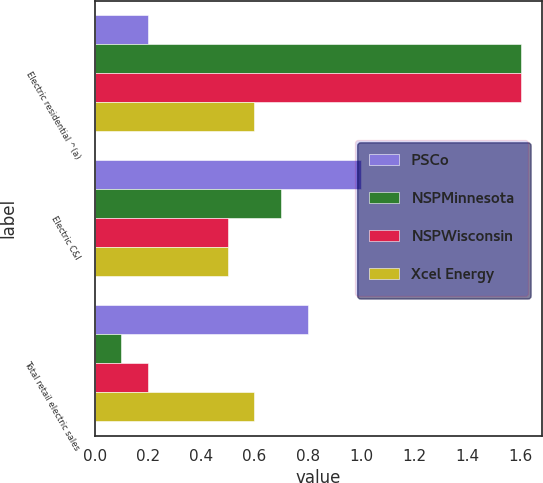Convert chart. <chart><loc_0><loc_0><loc_500><loc_500><stacked_bar_chart><ecel><fcel>Electric residential ^(a)<fcel>Electric C&I<fcel>Total retail electric sales<nl><fcel>PSCo<fcel>0.2<fcel>1<fcel>0.8<nl><fcel>NSPMinnesota<fcel>1.6<fcel>0.7<fcel>0.1<nl><fcel>NSPWisconsin<fcel>1.6<fcel>0.5<fcel>0.2<nl><fcel>Xcel Energy<fcel>0.6<fcel>0.5<fcel>0.6<nl></chart> 